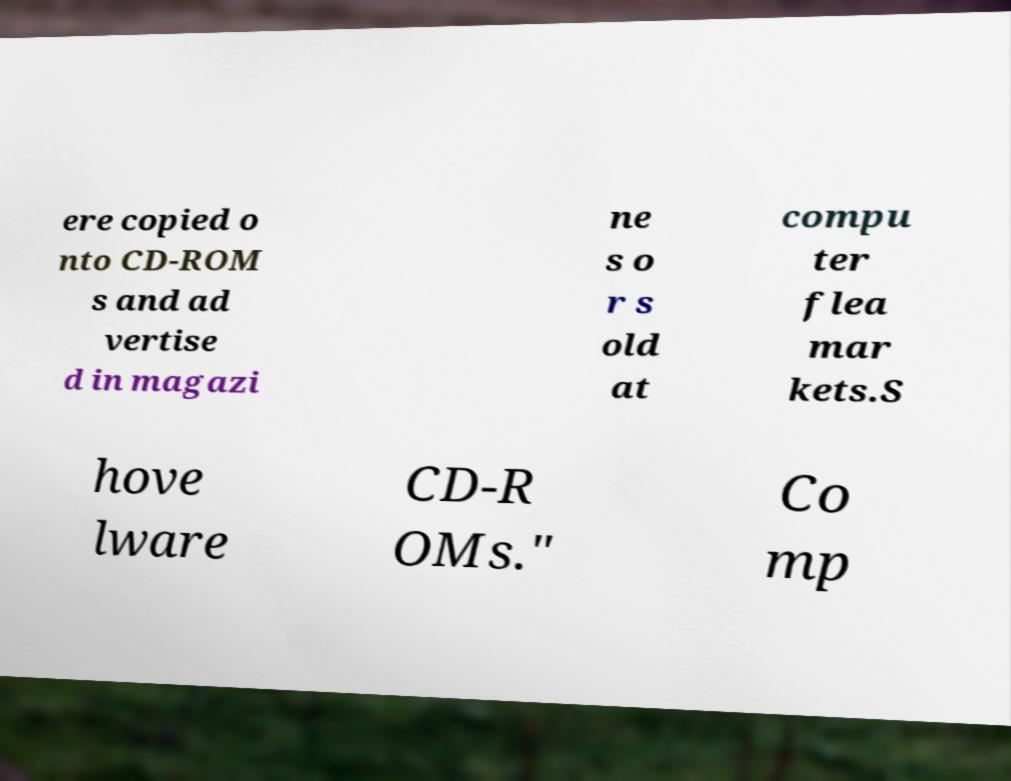What messages or text are displayed in this image? I need them in a readable, typed format. ere copied o nto CD-ROM s and ad vertise d in magazi ne s o r s old at compu ter flea mar kets.S hove lware CD-R OMs." Co mp 